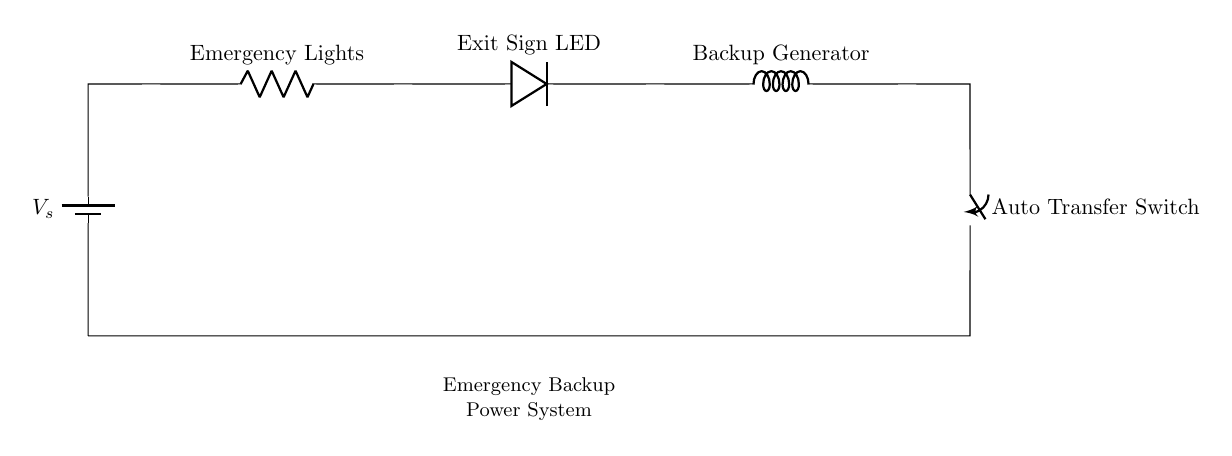What components are included in the circuit? The circuit includes a battery, a resistor for emergency lights, an LED for the exit sign, an inductor for the backup generator, and an auto transfer switch.
Answer: battery, resistor, LED, inductor, switch What is the role of the auto transfer switch? The auto transfer switch manages the connection between the primary power source and the backup power source, ensuring that the system switches automatically during a power outage.
Answer: power management How many components are in series? All components are connected in a single path, meaning there are five main components connected in series in this circuit: battery, resistor, LED, inductor, and switch.
Answer: five What does the backup generator do? The backup generator provides power to maintain functionality in the event of a power failure, serving as a secondary source of power in the system.
Answer: provides backup power Why is the emergency lights resistor present in the circuit? The resistor limits the current flowing to the emergency lights, preventing them from drawing excessive current that could lead to failures or damage in the circuit.
Answer: current limitation 